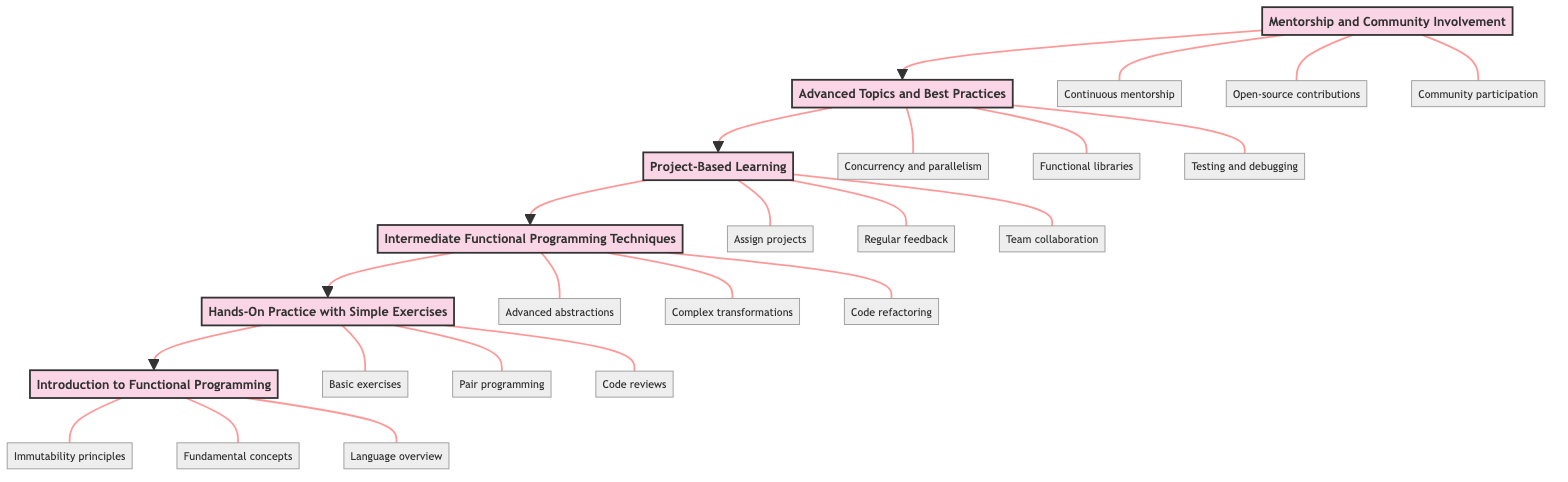What's the top stage in the diagram? The top stage represents the final point in the flowchart indicating the highest level of mentoring, which is "Mentorship and Community Involvement." This is the last node when following the flow from bottom to up.
Answer: Mentorship and Community Involvement How many main stages are presented in the diagram? By counting the distinct stages listed, there are six main stages that progress in the mentoring process, from introduction to community involvement.
Answer: Six What flow does "Project-Based Learning" have in relation to "Intermediate Functional Programming Techniques"? In the flowchart, "Project-Based Learning" directly follows "Intermediate Functional Programming Techniques." This indicates that after learning intermediate techniques, the next step is putting them into practice through projects.
Answer: Downward Which stage includes the topic of "Testing and debugging"? The stage that discusses "Testing and debugging" is "Advanced Topics and Best Practices." This stage focuses on maintaining and improving functional codebases, including aspects like debugging.
Answer: Advanced Topics and Best Practices How do the tasks in "Hands-On Practice with Simple Exercises" relate to "Introduction to Functional Programming"? The tasks in "Hands-On Practice with Simple Exercises" build directly on the foundational concepts introduced in "Introduction to Functional Programming," focusing on practical application through exercises and pair programming sessions. Thus, they are designed to take the theoretical knowledge from the first stage and apply it in practice.
Answer: Building on foundational concepts What is one task mentioned in the "Intermediate Functional Programming Techniques" stage? One task listed within the "Intermediate Functional Programming Techniques" stage includes exploring advanced abstractions such as monads, functors, and applicatives, indicating a focus on deeper functional programming concepts.
Answer: Explore advanced abstractions Which stage is directly below "Advanced Topics and Best Practices"? The stage directly below "Advanced Topics and Best Practices" is "Project-Based Learning," indicating a movement from advanced theoretical knowledge to practical project applications in functional programming.
Answer: Project-Based Learning 